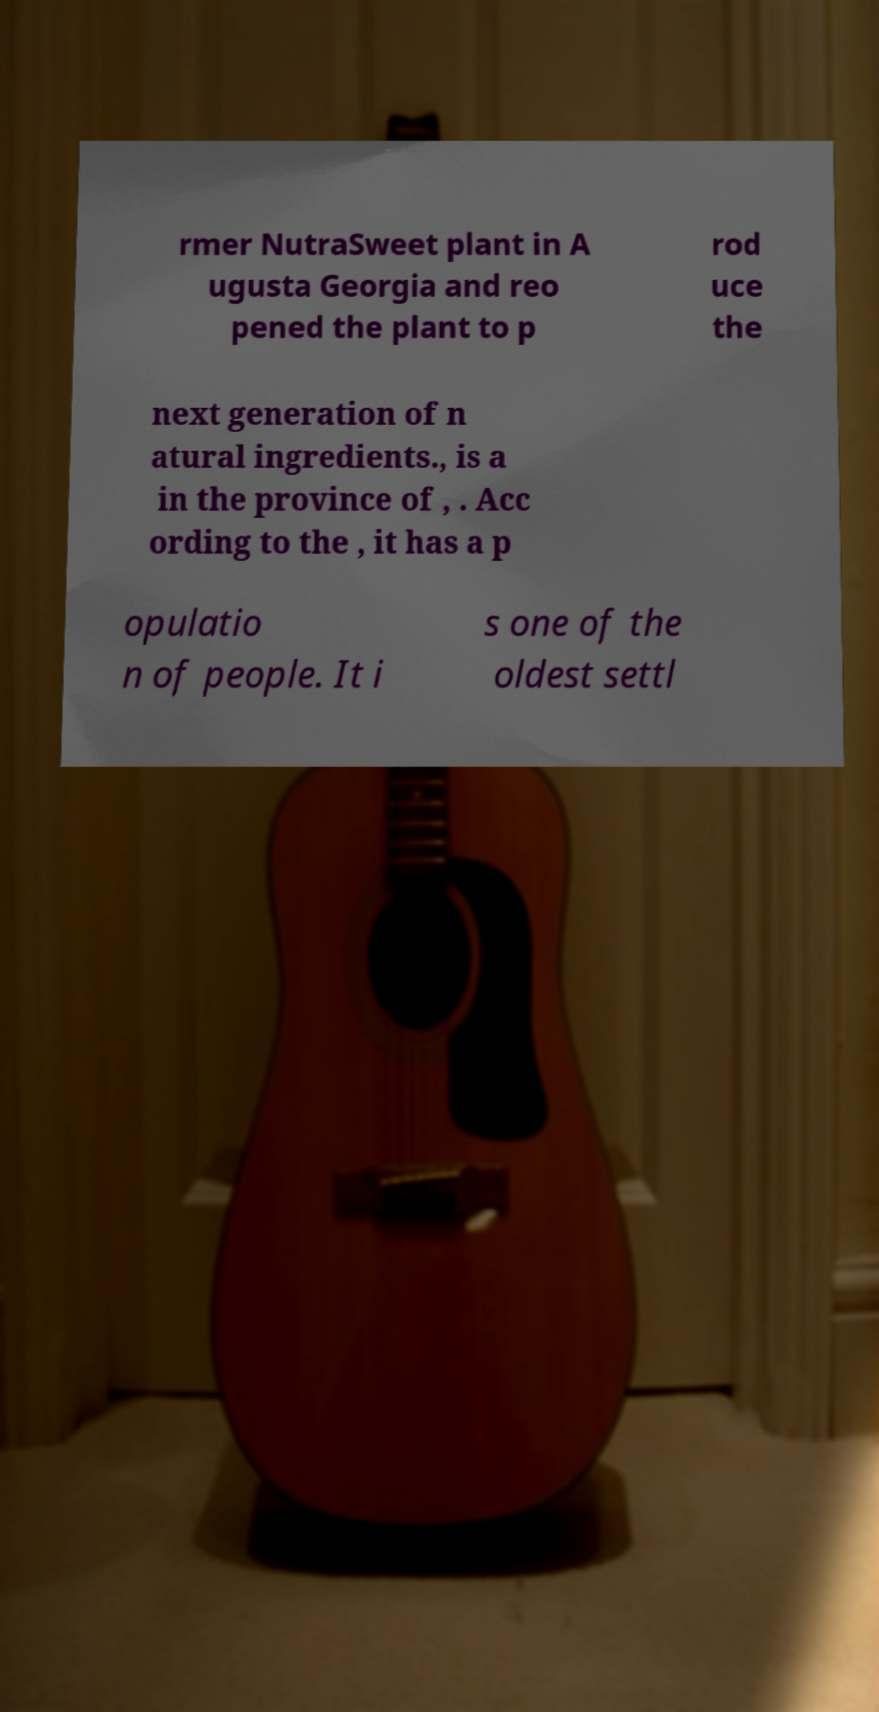Can you read and provide the text displayed in the image?This photo seems to have some interesting text. Can you extract and type it out for me? rmer NutraSweet plant in A ugusta Georgia and reo pened the plant to p rod uce the next generation of n atural ingredients., is a in the province of , . Acc ording to the , it has a p opulatio n of people. It i s one of the oldest settl 